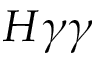<formula> <loc_0><loc_0><loc_500><loc_500>H \gamma \gamma</formula> 